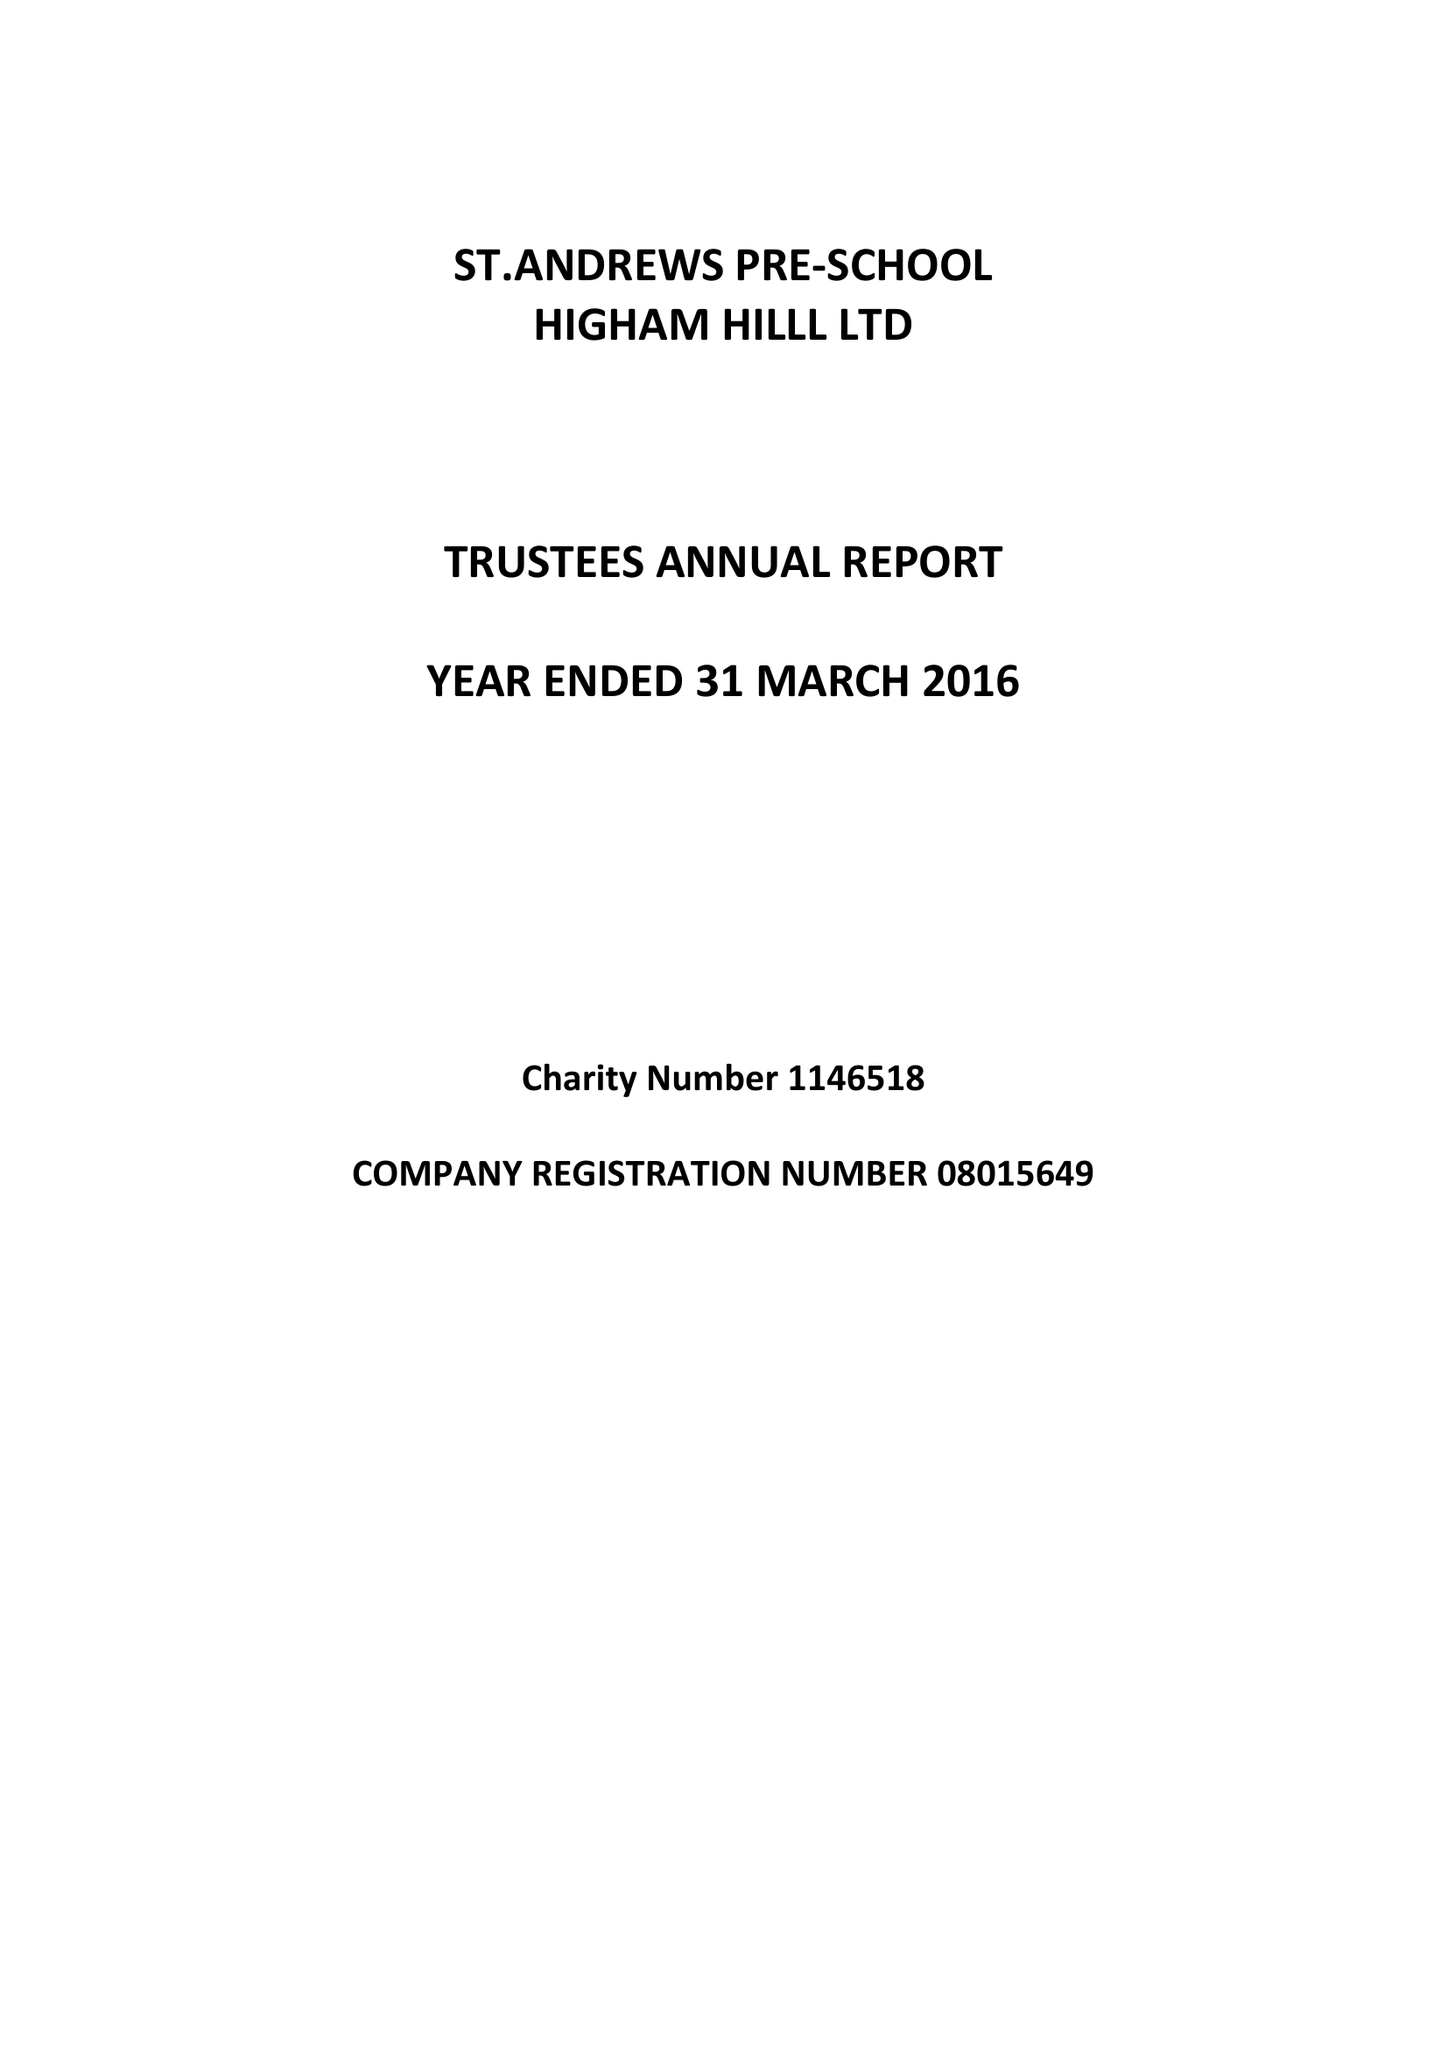What is the value for the charity_name?
Answer the question using a single word or phrase. St.Andrews Pre-School Higham Hill Ltd. 